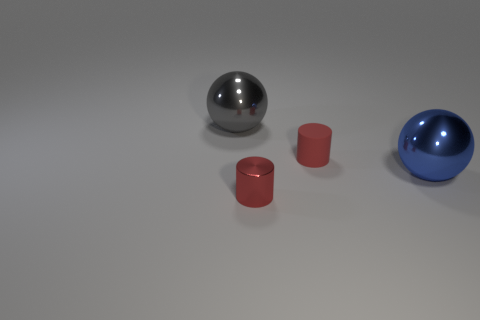There is another metallic object that is the same size as the gray object; what is its shape?
Your answer should be very brief. Sphere. Is the object behind the red matte cylinder made of the same material as the large ball that is in front of the small red rubber cylinder?
Your response must be concise. Yes. Is there a gray thing on the left side of the blue metal object that is in front of the matte cylinder?
Provide a succinct answer. Yes. There is a tiny thing that is made of the same material as the gray sphere; what color is it?
Your answer should be compact. Red. Are there more big spheres than things?
Your answer should be compact. No. What number of things are either large shiny things that are on the left side of the big blue metallic thing or small matte cylinders?
Offer a very short reply. 2. Are there any red matte cylinders that have the same size as the gray metallic object?
Provide a short and direct response. No. Is the number of small metallic cylinders less than the number of shiny balls?
Your answer should be compact. Yes. What number of balls are big gray objects or red things?
Make the answer very short. 1. How many tiny matte cylinders have the same color as the tiny shiny thing?
Provide a succinct answer. 1. 